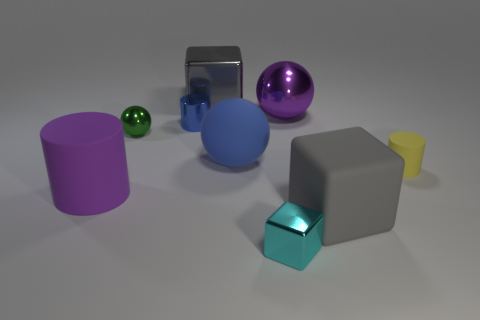What number of large blue rubber balls are there? There is one large blue rubber ball visible in the image among other objects of various shapes and colors. 